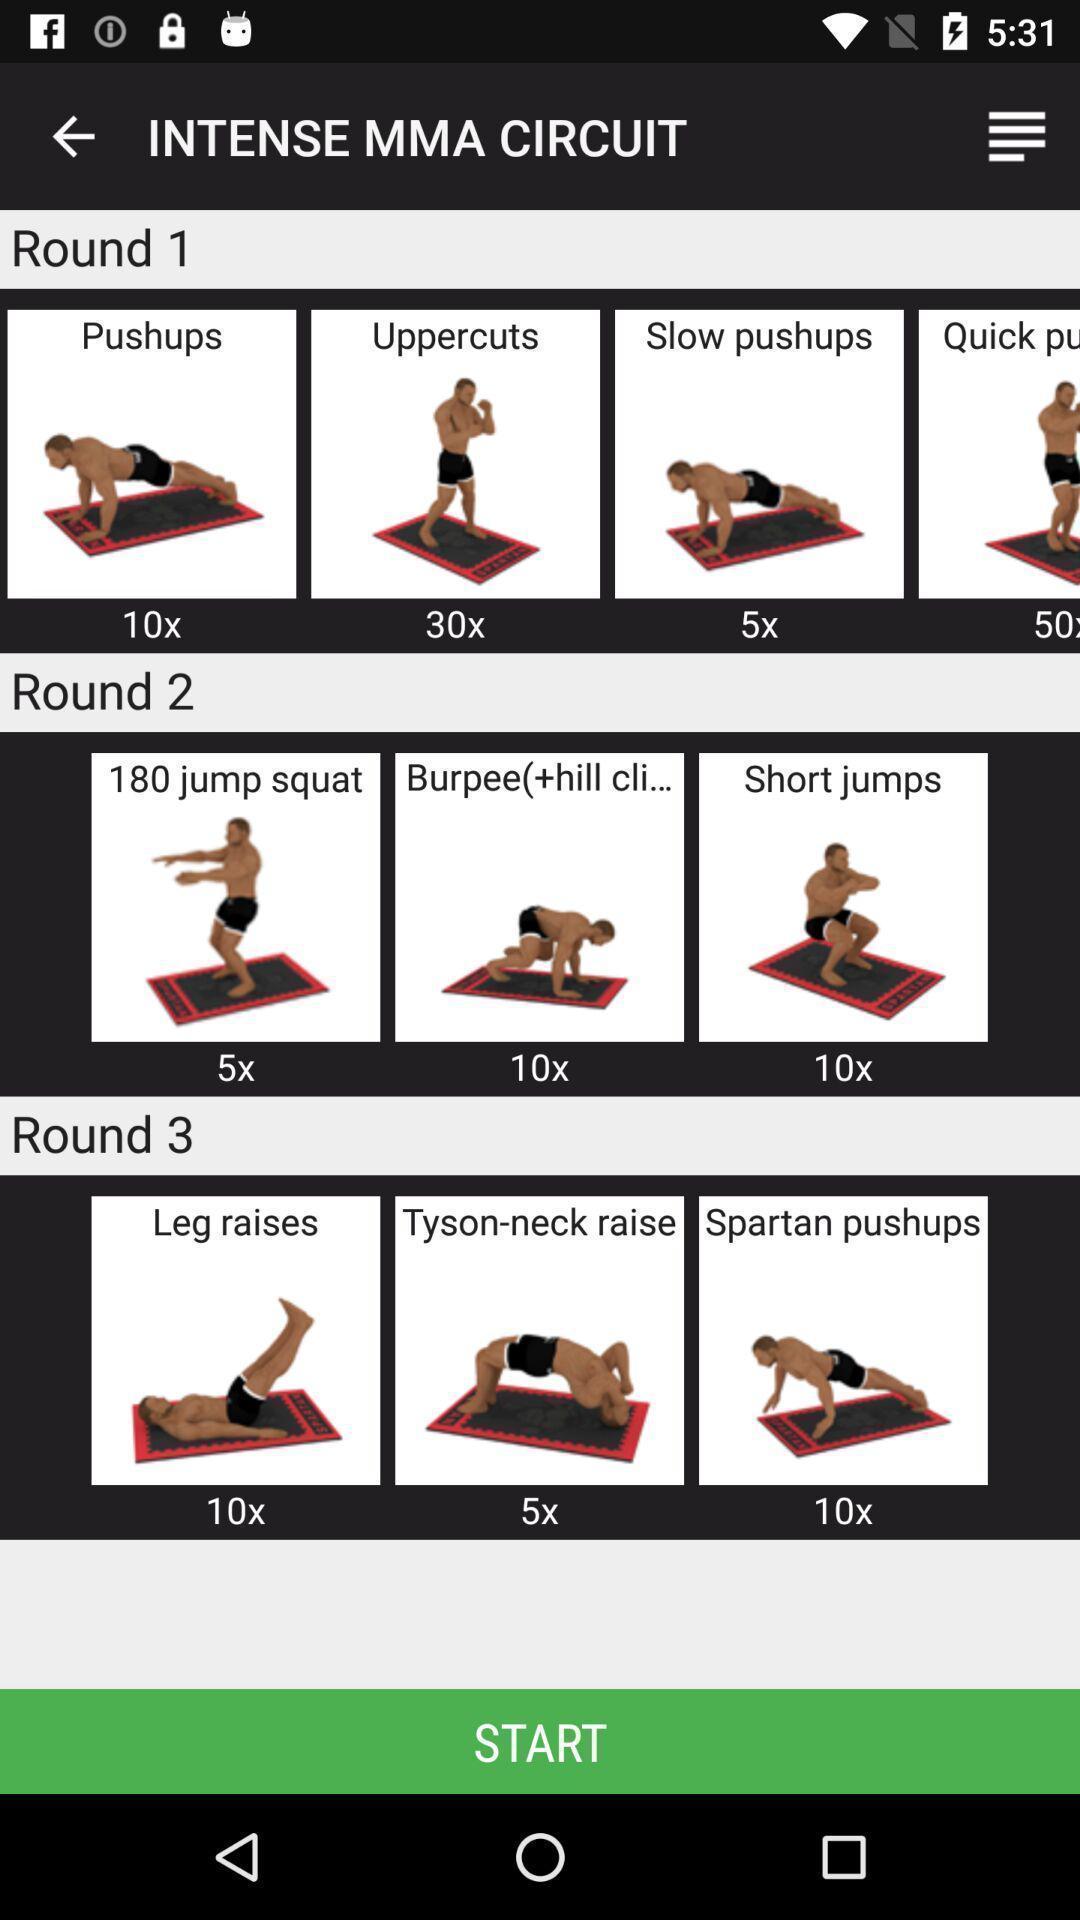Provide a description of this screenshot. Page showing the images of yoga. 